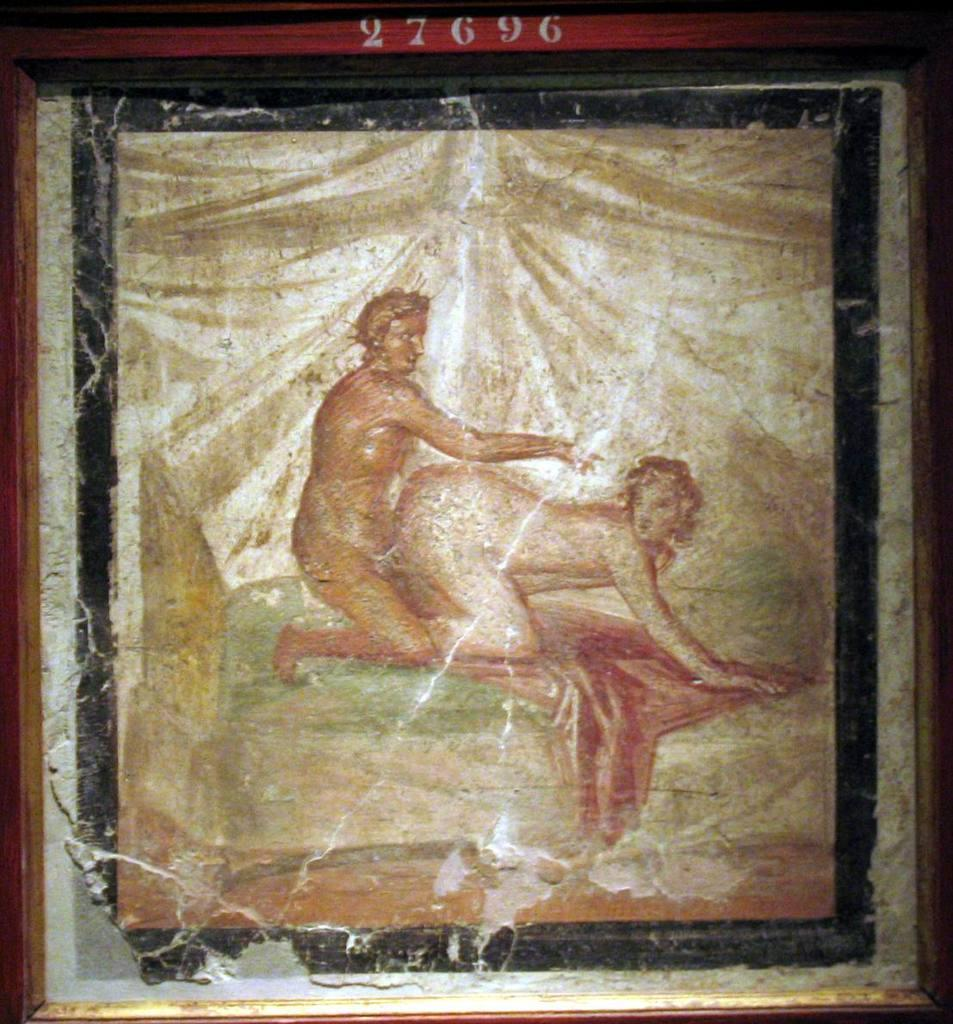What is the main object in the image? There is a frame in the image. What is inside the frame? The frame contains a painting. What is the subject of the painting? The painting depicts two persons. What type of chalk can be seen in the painting? There is no chalk present in the painting; it depicts two persons. What type of animals can be seen at the zoo in the image? There is no zoo present in the image; it features a frame with a painting of two persons. 